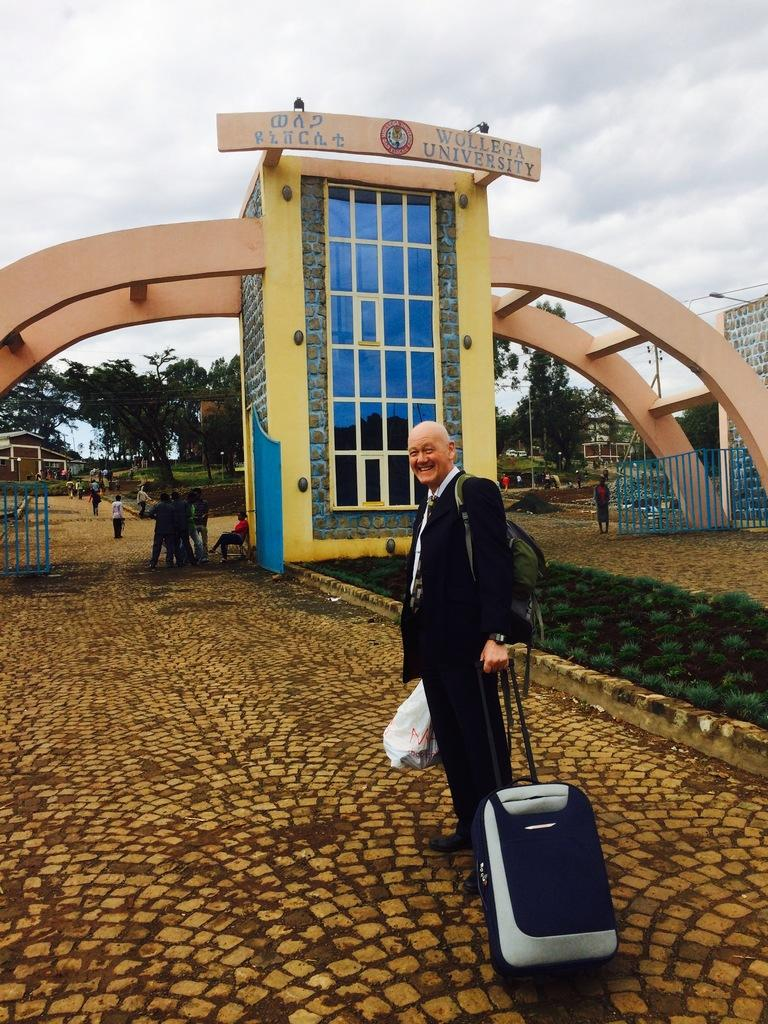What is the person in the image doing? The person is standing with a trolley in the image. What is the person standing on? The person is standing on the ground. What type of trees can be seen in the background of the image? There are larch trees and other trees in the background of the image. What type of vegetation is present in the background of the image? Grass is present in the background of the image. Are there any other people visible in the image? Yes, there are other persons in the background of the image. What is visible in the sky in the image? The sky is visible in the background of the image, and clouds are present. What type of hair product is being used by the person in the image? There is no indication in the image that the person is using any hair product. What type of butter is being spread on the trees in the image? There is no butter present in the image, and the trees are not being used for spreading butter. 